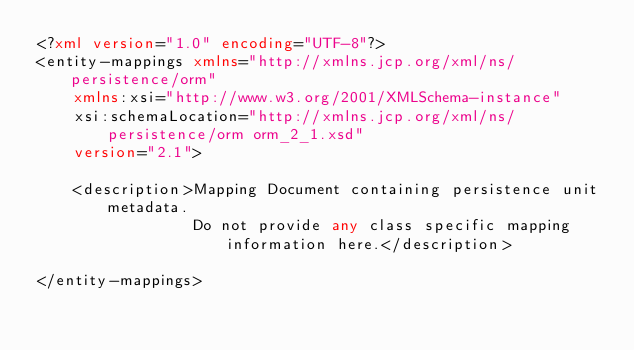<code> <loc_0><loc_0><loc_500><loc_500><_XML_><?xml version="1.0" encoding="UTF-8"?>
<entity-mappings xmlns="http://xmlns.jcp.org/xml/ns/persistence/orm"
    xmlns:xsi="http://www.w3.org/2001/XMLSchema-instance"
    xsi:schemaLocation="http://xmlns.jcp.org/xml/ns/persistence/orm orm_2_1.xsd"
    version="2.1">

    <description>Mapping Document containing persistence unit metadata.
                 Do not provide any class specific mapping information here.</description>

</entity-mappings>
</code> 